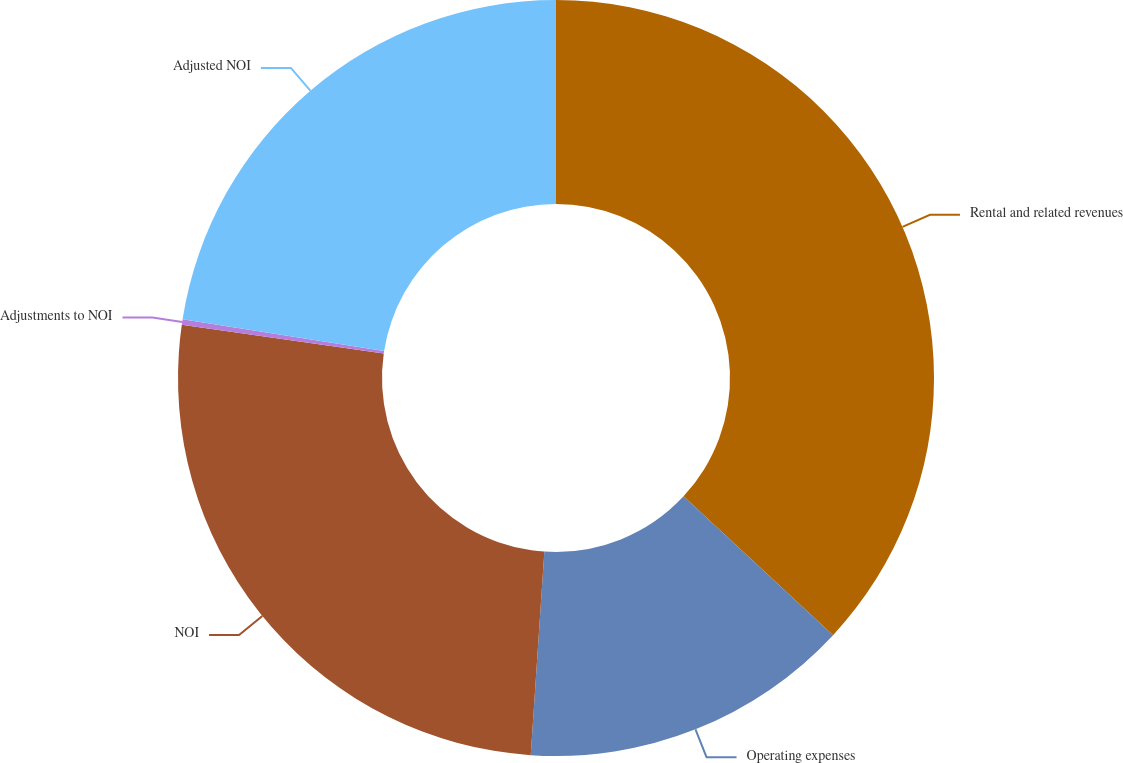<chart> <loc_0><loc_0><loc_500><loc_500><pie_chart><fcel>Rental and related revenues<fcel>Operating expenses<fcel>NOI<fcel>Adjustments to NOI<fcel>Adjusted NOI<nl><fcel>36.91%<fcel>14.16%<fcel>26.19%<fcel>0.23%<fcel>22.52%<nl></chart> 